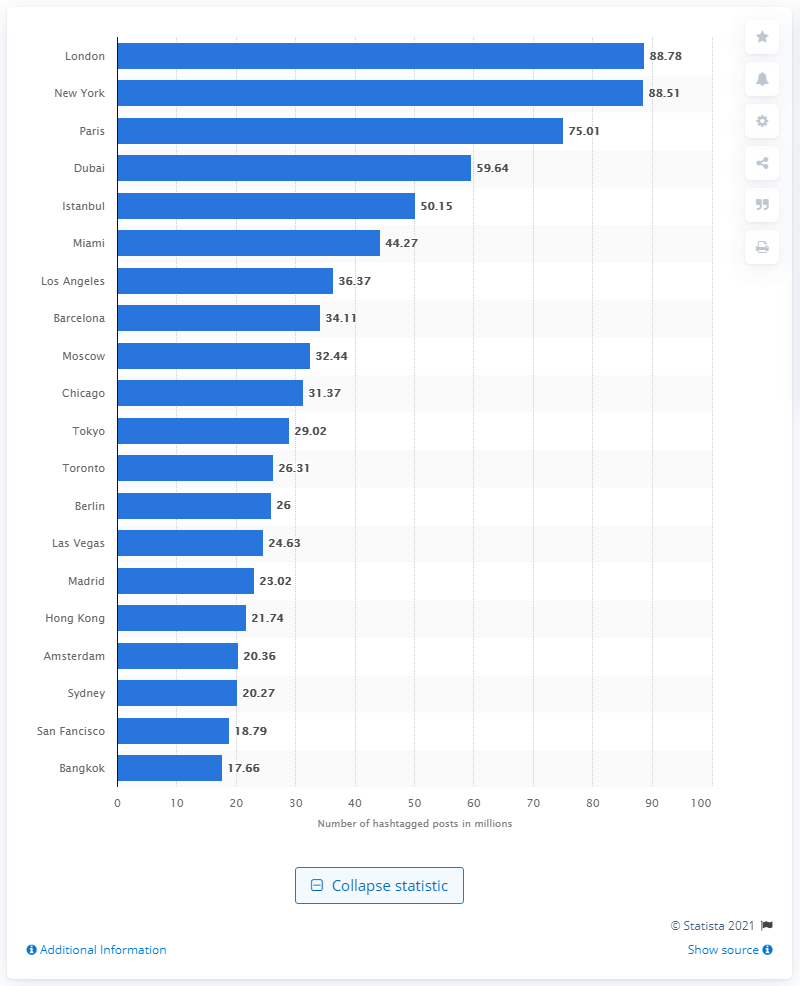Give some essential details in this illustration. In December 2017, there were 88.78 mentions of London on Instagram. As of December 2017, London was the most popular city on Instagram. 